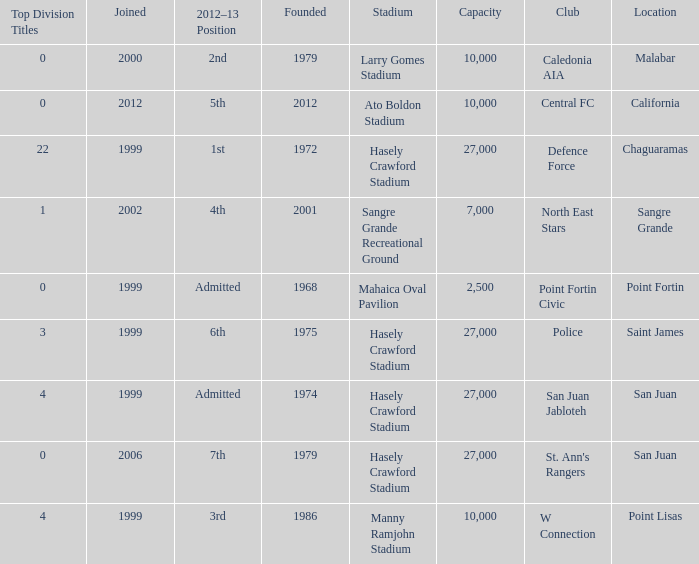For teams located in chaguaramas and established before 1975, what is the total number of top division titles achieved? 22.0. 